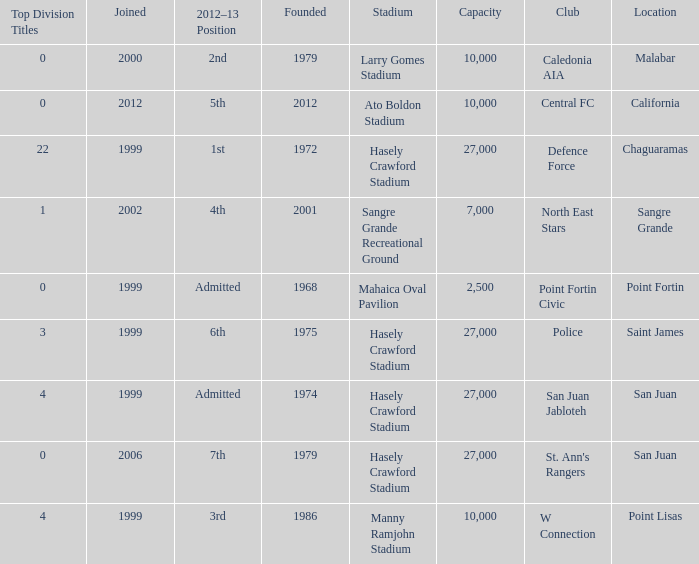For teams located in chaguaramas and established before 1975, what is the total number of top division titles achieved? 22.0. 